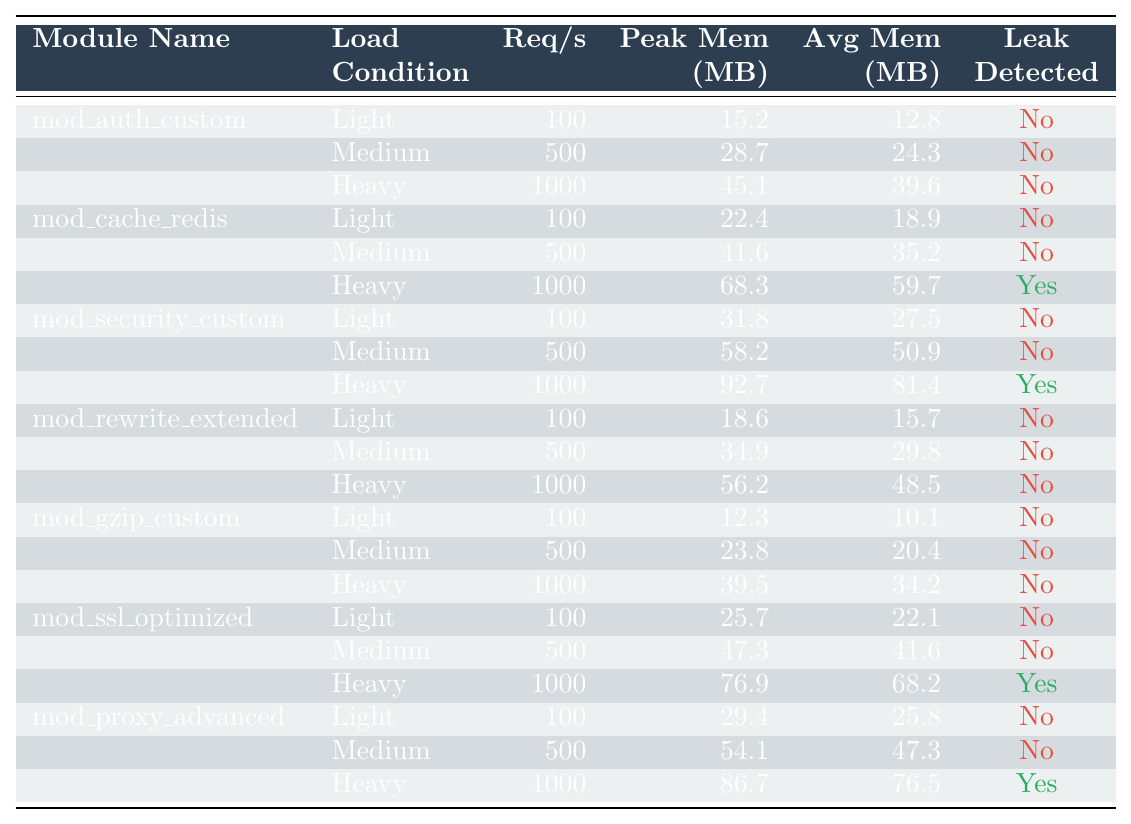What is the peak memory usage of the "mod_ssl_optimized" module under heavy load? The table shows that for the "mod_ssl_optimized" module under heavy load (1000 requests per second), the peak memory usage is listed as 76.9 MB.
Answer: 76.9 MB Which module detected a memory leak under heavy load? The table indicates that both "mod_cache_redis" and "mod_security_custom" detected memory leaks under heavy load as they have "Yes" marked in the "Leak Detected" column.
Answer: mod_cache_redis, mod_security_custom What is the average memory usage of "mod_auth_custom" under medium load? According to the table, the average memory usage for "mod_auth_custom" under medium load (500 requests per second) is listed as 24.3 MB.
Answer: 24.3 MB How does the peak memory usage of "mod_proxy_advanced" under heavy load compare to that of "mod_rewrite_extended" under the same load? The peak memory usage for "mod_proxy_advanced" under heavy load is 86.7 MB, while for "mod_rewrite_extended" it is 56.2 MB. The difference is 30.5 MB, indicating that "mod_proxy_advanced" uses significantly more memory.
Answer: 30.5 MB What is the average memory usage of the "mod_cache_redis" module across all load conditions? The average memory usage for "mod_cache_redis": Light (18.9 MB), Medium (35.2 MB), Heavy (59.7 MB). Summing these: 18.9 + 35.2 + 59.7 = 113.8 MB. There are 3 conditions, so the average is 113.8/3 = 37.93 MB.
Answer: 37.93 MB Under which load condition does "mod_gzip_custom" use the least peak memory? The table shows that under light load, "mod_gzip_custom" uses the least peak memory at 12.3 MB.
Answer: Light load What is the module with the highest average memory usage under heavy load? Under heavy load, "mod_security_custom" has the highest average memory usage at 81.4 MB.
Answer: mod_security_custom Is the average memory usage of "mod_ssl_optimized" under heavy load greater than 70 MB? The average memory usage for "mod_ssl_optimized" under heavy load is 68.2 MB, which is less than 70 MB.
Answer: No Which load condition causes the most significant increase in peak memory usage for "mod_cache_redis"? The peak memory usage for "mod_cache_redis" rises from 22.4 MB (light) to 41.6 MB (medium) to 68.3 MB (heavy). The most significant increase occurs from medium to heavy load, with an increase of 27.1 MB.
Answer: Heavy load What is the difference in requests per second between light and heavy load for "mod_auth_custom"? For "mod_auth_custom", light load is 100 requests per second and heavy load is 1000 requests per second. The difference is 1000 - 100 = 900 requests per second.
Answer: 900 requests per second 